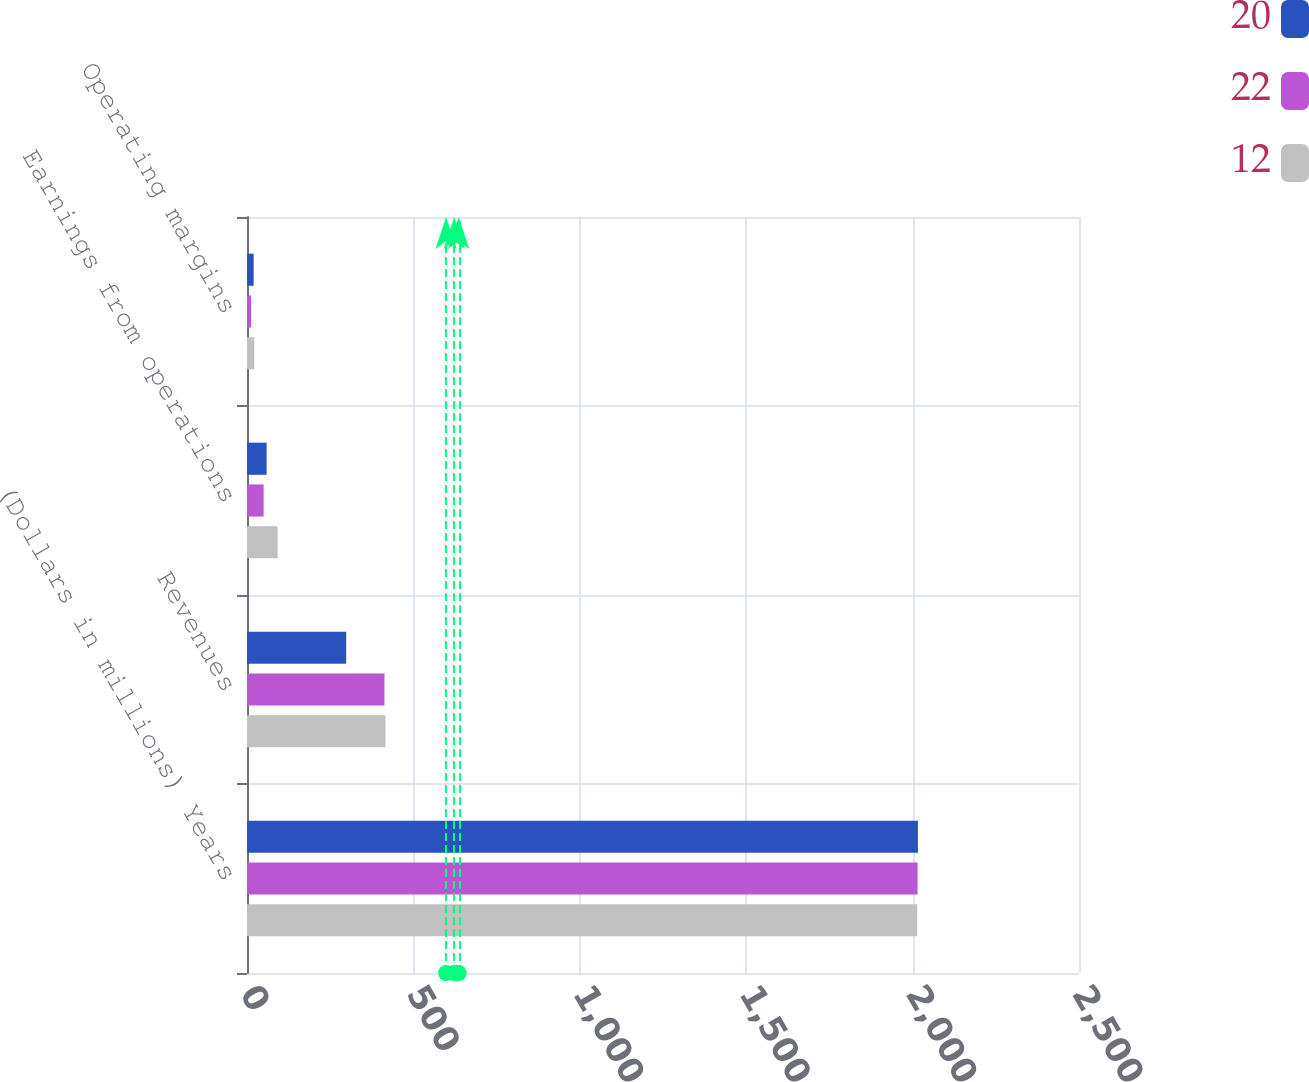Convert chart. <chart><loc_0><loc_0><loc_500><loc_500><stacked_bar_chart><ecel><fcel>(Dollars in millions) Years<fcel>Revenues<fcel>Earnings from operations<fcel>Operating margins<nl><fcel>20<fcel>2016<fcel>298<fcel>59<fcel>20<nl><fcel>22<fcel>2015<fcel>413<fcel>50<fcel>12<nl><fcel>12<fcel>2014<fcel>416<fcel>92<fcel>22<nl></chart> 